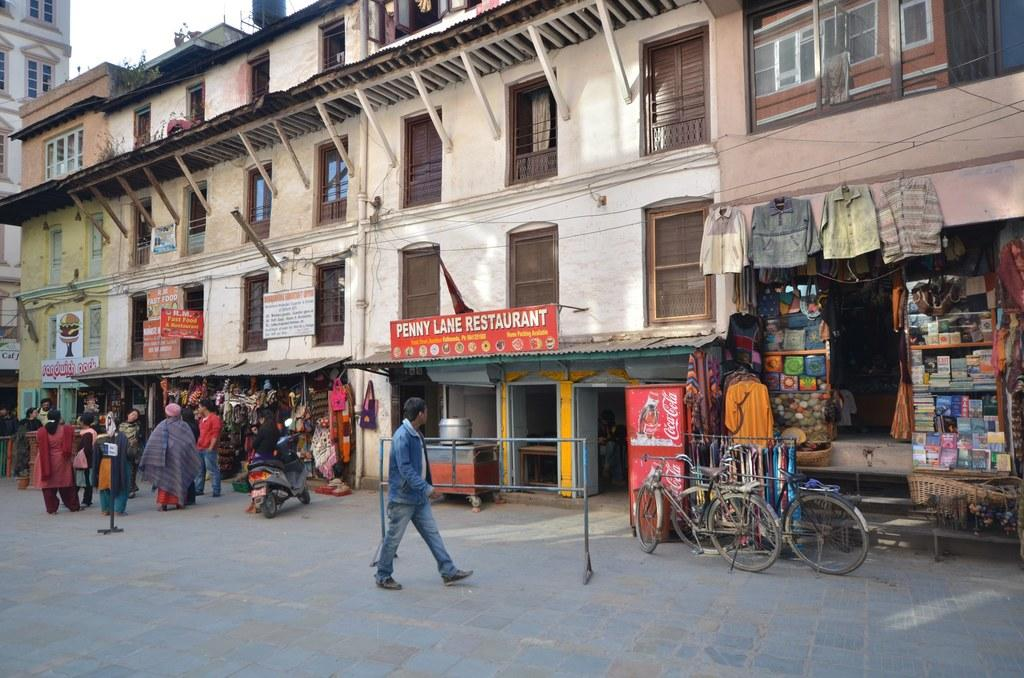<image>
Present a compact description of the photo's key features. A man walks past penny lane restaurant on an unknown street. 